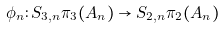Convert formula to latex. <formula><loc_0><loc_0><loc_500><loc_500>\phi _ { n } \colon S _ { 3 , n } \pi _ { 3 } ( A _ { n } ) \to S _ { 2 , n } \pi _ { 2 } ( A _ { n } )</formula> 